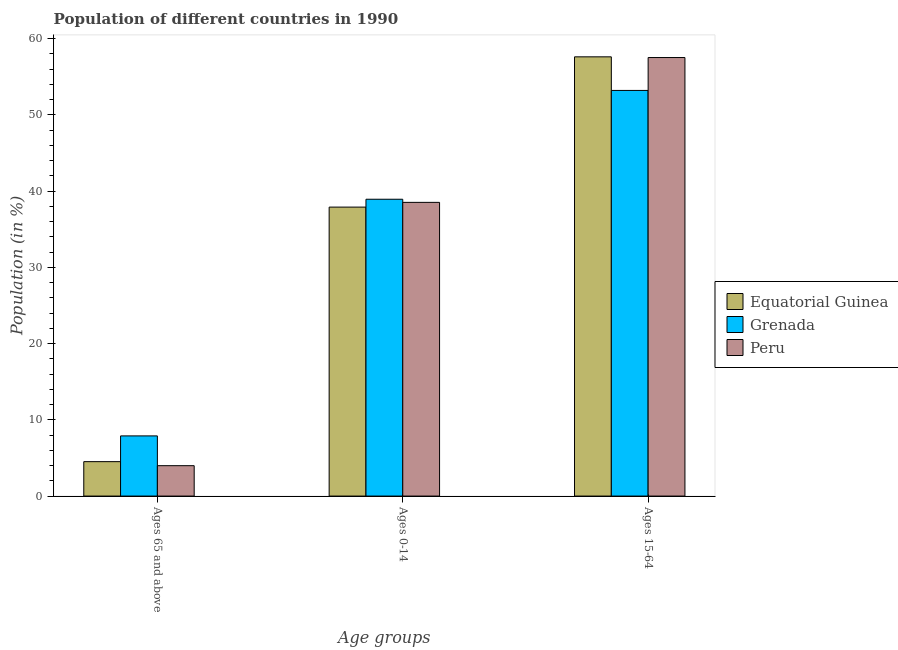How many groups of bars are there?
Your response must be concise. 3. Are the number of bars per tick equal to the number of legend labels?
Your response must be concise. Yes. Are the number of bars on each tick of the X-axis equal?
Provide a succinct answer. Yes. How many bars are there on the 2nd tick from the left?
Provide a short and direct response. 3. What is the label of the 1st group of bars from the left?
Provide a succinct answer. Ages 65 and above. What is the percentage of population within the age-group of 65 and above in Equatorial Guinea?
Provide a short and direct response. 4.51. Across all countries, what is the maximum percentage of population within the age-group 0-14?
Your answer should be very brief. 38.92. Across all countries, what is the minimum percentage of population within the age-group 0-14?
Your answer should be very brief. 37.89. In which country was the percentage of population within the age-group of 65 and above maximum?
Offer a terse response. Grenada. In which country was the percentage of population within the age-group 0-14 minimum?
Ensure brevity in your answer.  Equatorial Guinea. What is the total percentage of population within the age-group of 65 and above in the graph?
Provide a succinct answer. 16.39. What is the difference between the percentage of population within the age-group of 65 and above in Equatorial Guinea and that in Grenada?
Give a very brief answer. -3.38. What is the difference between the percentage of population within the age-group 0-14 in Peru and the percentage of population within the age-group 15-64 in Grenada?
Provide a short and direct response. -14.68. What is the average percentage of population within the age-group 15-64 per country?
Provide a succinct answer. 56.1. What is the difference between the percentage of population within the age-group of 65 and above and percentage of population within the age-group 0-14 in Equatorial Guinea?
Ensure brevity in your answer.  -33.38. What is the ratio of the percentage of population within the age-group 15-64 in Peru to that in Equatorial Guinea?
Offer a terse response. 1. What is the difference between the highest and the second highest percentage of population within the age-group 15-64?
Your answer should be compact. 0.09. What is the difference between the highest and the lowest percentage of population within the age-group of 65 and above?
Your answer should be compact. 3.9. Is the sum of the percentage of population within the age-group of 65 and above in Grenada and Equatorial Guinea greater than the maximum percentage of population within the age-group 15-64 across all countries?
Ensure brevity in your answer.  No. What does the 2nd bar from the left in Ages 0-14 represents?
Provide a succinct answer. Grenada. Does the graph contain any zero values?
Offer a terse response. No. Where does the legend appear in the graph?
Ensure brevity in your answer.  Center right. How are the legend labels stacked?
Provide a succinct answer. Vertical. What is the title of the graph?
Provide a short and direct response. Population of different countries in 1990. Does "Ukraine" appear as one of the legend labels in the graph?
Offer a very short reply. No. What is the label or title of the X-axis?
Offer a very short reply. Age groups. What is the Population (in %) in Equatorial Guinea in Ages 65 and above?
Keep it short and to the point. 4.51. What is the Population (in %) of Grenada in Ages 65 and above?
Offer a very short reply. 7.89. What is the Population (in %) of Peru in Ages 65 and above?
Offer a terse response. 3.99. What is the Population (in %) of Equatorial Guinea in Ages 0-14?
Ensure brevity in your answer.  37.89. What is the Population (in %) in Grenada in Ages 0-14?
Provide a short and direct response. 38.92. What is the Population (in %) in Peru in Ages 0-14?
Your answer should be compact. 38.51. What is the Population (in %) of Equatorial Guinea in Ages 15-64?
Ensure brevity in your answer.  57.6. What is the Population (in %) of Grenada in Ages 15-64?
Make the answer very short. 53.19. What is the Population (in %) in Peru in Ages 15-64?
Ensure brevity in your answer.  57.5. Across all Age groups, what is the maximum Population (in %) of Equatorial Guinea?
Make the answer very short. 57.6. Across all Age groups, what is the maximum Population (in %) of Grenada?
Offer a very short reply. 53.19. Across all Age groups, what is the maximum Population (in %) in Peru?
Provide a short and direct response. 57.5. Across all Age groups, what is the minimum Population (in %) in Equatorial Guinea?
Your answer should be very brief. 4.51. Across all Age groups, what is the minimum Population (in %) of Grenada?
Keep it short and to the point. 7.89. Across all Age groups, what is the minimum Population (in %) of Peru?
Your answer should be compact. 3.99. What is the total Population (in %) in Grenada in the graph?
Your answer should be very brief. 100. What is the difference between the Population (in %) in Equatorial Guinea in Ages 65 and above and that in Ages 0-14?
Offer a terse response. -33.38. What is the difference between the Population (in %) of Grenada in Ages 65 and above and that in Ages 0-14?
Your answer should be compact. -31.03. What is the difference between the Population (in %) of Peru in Ages 65 and above and that in Ages 0-14?
Your response must be concise. -34.53. What is the difference between the Population (in %) in Equatorial Guinea in Ages 65 and above and that in Ages 15-64?
Your answer should be compact. -53.08. What is the difference between the Population (in %) of Grenada in Ages 65 and above and that in Ages 15-64?
Your answer should be compact. -45.3. What is the difference between the Population (in %) in Peru in Ages 65 and above and that in Ages 15-64?
Your answer should be compact. -53.52. What is the difference between the Population (in %) of Equatorial Guinea in Ages 0-14 and that in Ages 15-64?
Your response must be concise. -19.7. What is the difference between the Population (in %) of Grenada in Ages 0-14 and that in Ages 15-64?
Offer a terse response. -14.27. What is the difference between the Population (in %) in Peru in Ages 0-14 and that in Ages 15-64?
Offer a terse response. -18.99. What is the difference between the Population (in %) of Equatorial Guinea in Ages 65 and above and the Population (in %) of Grenada in Ages 0-14?
Give a very brief answer. -34.41. What is the difference between the Population (in %) of Equatorial Guinea in Ages 65 and above and the Population (in %) of Peru in Ages 0-14?
Your answer should be compact. -34. What is the difference between the Population (in %) in Grenada in Ages 65 and above and the Population (in %) in Peru in Ages 0-14?
Ensure brevity in your answer.  -30.62. What is the difference between the Population (in %) in Equatorial Guinea in Ages 65 and above and the Population (in %) in Grenada in Ages 15-64?
Provide a succinct answer. -48.68. What is the difference between the Population (in %) in Equatorial Guinea in Ages 65 and above and the Population (in %) in Peru in Ages 15-64?
Keep it short and to the point. -52.99. What is the difference between the Population (in %) in Grenada in Ages 65 and above and the Population (in %) in Peru in Ages 15-64?
Offer a terse response. -49.61. What is the difference between the Population (in %) in Equatorial Guinea in Ages 0-14 and the Population (in %) in Grenada in Ages 15-64?
Provide a short and direct response. -15.3. What is the difference between the Population (in %) in Equatorial Guinea in Ages 0-14 and the Population (in %) in Peru in Ages 15-64?
Your answer should be compact. -19.61. What is the difference between the Population (in %) in Grenada in Ages 0-14 and the Population (in %) in Peru in Ages 15-64?
Give a very brief answer. -18.58. What is the average Population (in %) of Equatorial Guinea per Age groups?
Provide a short and direct response. 33.33. What is the average Population (in %) of Grenada per Age groups?
Keep it short and to the point. 33.33. What is the average Population (in %) of Peru per Age groups?
Provide a short and direct response. 33.33. What is the difference between the Population (in %) of Equatorial Guinea and Population (in %) of Grenada in Ages 65 and above?
Offer a very short reply. -3.38. What is the difference between the Population (in %) in Equatorial Guinea and Population (in %) in Peru in Ages 65 and above?
Your answer should be very brief. 0.53. What is the difference between the Population (in %) of Grenada and Population (in %) of Peru in Ages 65 and above?
Provide a short and direct response. 3.9. What is the difference between the Population (in %) of Equatorial Guinea and Population (in %) of Grenada in Ages 0-14?
Provide a succinct answer. -1.03. What is the difference between the Population (in %) in Equatorial Guinea and Population (in %) in Peru in Ages 0-14?
Your answer should be compact. -0.62. What is the difference between the Population (in %) in Grenada and Population (in %) in Peru in Ages 0-14?
Ensure brevity in your answer.  0.41. What is the difference between the Population (in %) in Equatorial Guinea and Population (in %) in Grenada in Ages 15-64?
Your response must be concise. 4.41. What is the difference between the Population (in %) in Equatorial Guinea and Population (in %) in Peru in Ages 15-64?
Keep it short and to the point. 0.09. What is the difference between the Population (in %) of Grenada and Population (in %) of Peru in Ages 15-64?
Ensure brevity in your answer.  -4.31. What is the ratio of the Population (in %) of Equatorial Guinea in Ages 65 and above to that in Ages 0-14?
Ensure brevity in your answer.  0.12. What is the ratio of the Population (in %) in Grenada in Ages 65 and above to that in Ages 0-14?
Keep it short and to the point. 0.2. What is the ratio of the Population (in %) of Peru in Ages 65 and above to that in Ages 0-14?
Ensure brevity in your answer.  0.1. What is the ratio of the Population (in %) in Equatorial Guinea in Ages 65 and above to that in Ages 15-64?
Give a very brief answer. 0.08. What is the ratio of the Population (in %) of Grenada in Ages 65 and above to that in Ages 15-64?
Ensure brevity in your answer.  0.15. What is the ratio of the Population (in %) in Peru in Ages 65 and above to that in Ages 15-64?
Provide a short and direct response. 0.07. What is the ratio of the Population (in %) of Equatorial Guinea in Ages 0-14 to that in Ages 15-64?
Make the answer very short. 0.66. What is the ratio of the Population (in %) in Grenada in Ages 0-14 to that in Ages 15-64?
Make the answer very short. 0.73. What is the ratio of the Population (in %) of Peru in Ages 0-14 to that in Ages 15-64?
Your response must be concise. 0.67. What is the difference between the highest and the second highest Population (in %) in Equatorial Guinea?
Provide a short and direct response. 19.7. What is the difference between the highest and the second highest Population (in %) of Grenada?
Provide a succinct answer. 14.27. What is the difference between the highest and the second highest Population (in %) of Peru?
Offer a very short reply. 18.99. What is the difference between the highest and the lowest Population (in %) in Equatorial Guinea?
Offer a terse response. 53.08. What is the difference between the highest and the lowest Population (in %) of Grenada?
Keep it short and to the point. 45.3. What is the difference between the highest and the lowest Population (in %) of Peru?
Offer a very short reply. 53.52. 